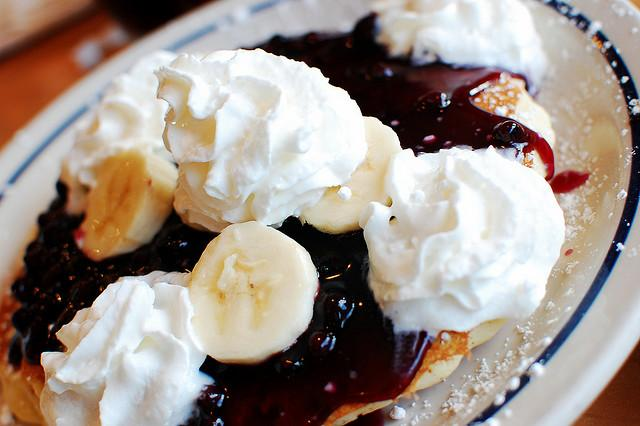What type of breakfast food is this on the plate? pancakes 